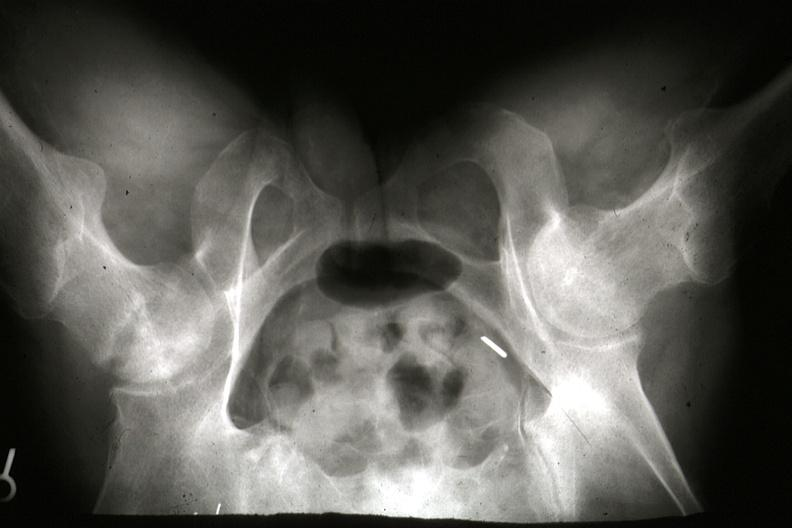what are gross and postmortx-rays of this lesion?
Answer the question using a single word or phrase. 7182 7183 